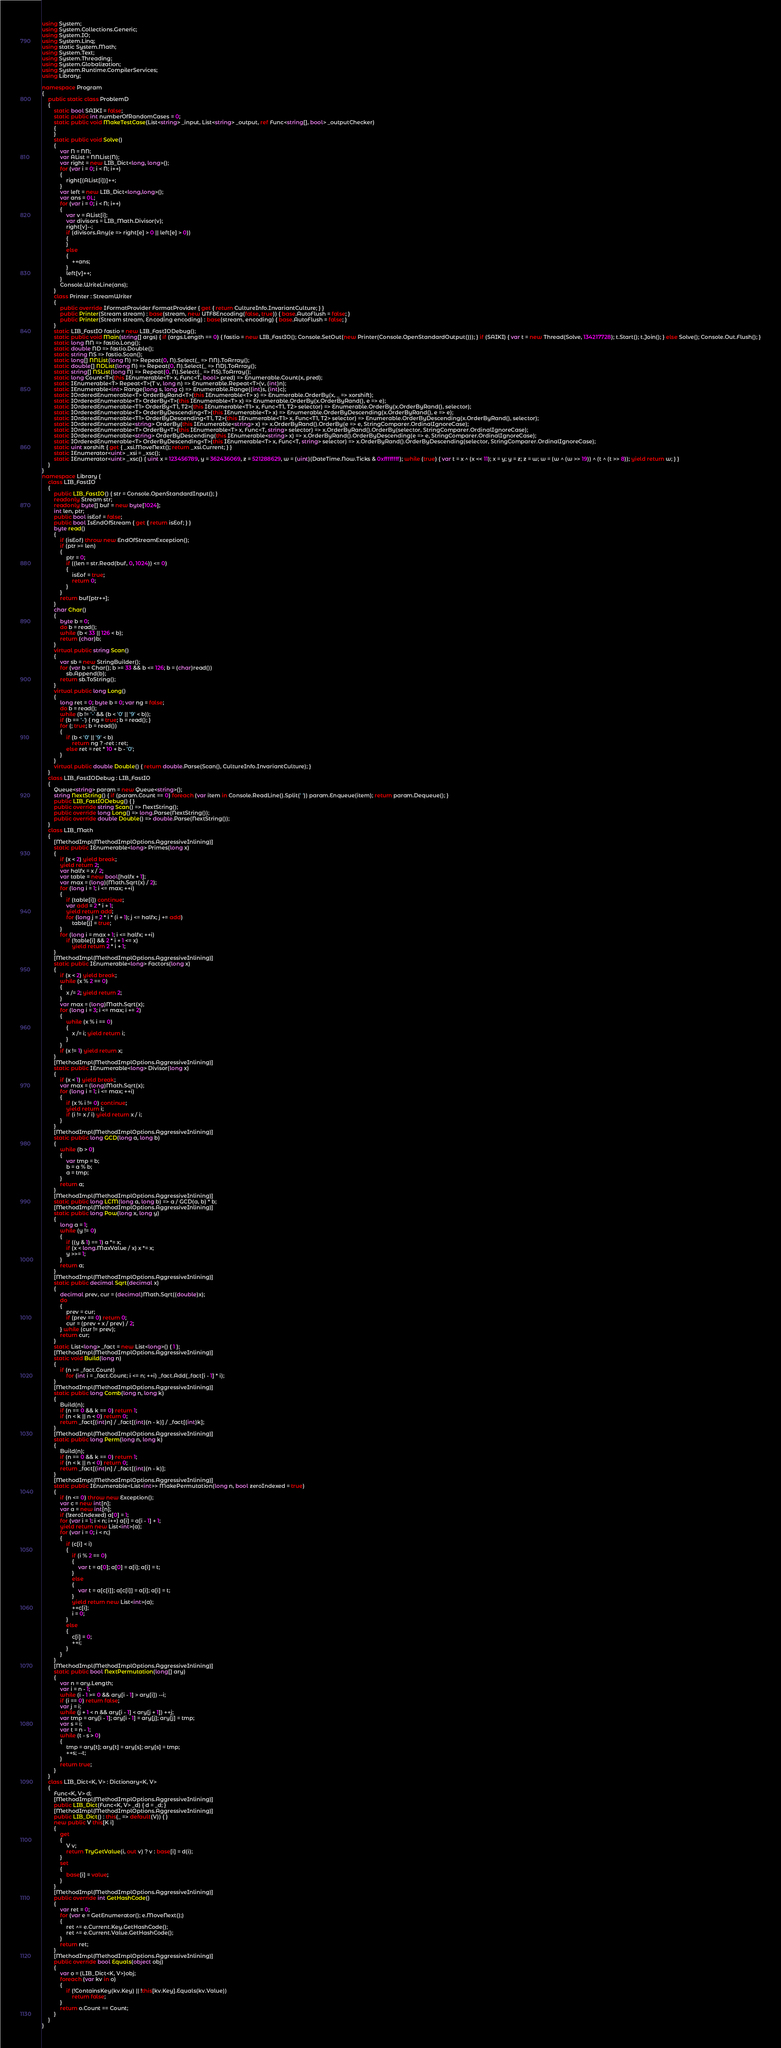<code> <loc_0><loc_0><loc_500><loc_500><_C#_>using System;
using System.Collections.Generic;
using System.IO;
using System.Linq;
using static System.Math;
using System.Text;
using System.Threading;
using System.Globalization;
using System.Runtime.CompilerServices;
using Library;

namespace Program
{
    public static class ProblemD
    {
        static bool SAIKI = false;
        static public int numberOfRandomCases = 0;
        static public void MakeTestCase(List<string> _input, List<string> _output, ref Func<string[], bool> _outputChecker)
        {
        }
        static public void Solve()
        {
            var N = NN;
            var AList = NNList(N);
            var right = new LIB_Dict<long, long>();
            for (var i = 0; i < N; i++)
            {
                right[(AList[i])]++;
            }
            var left = new LIB_Dict<long,long>();
            var ans = 0L;
            for (var i = 0; i < N; i++)
            {
                var v = AList[i];
                var divisors = LIB_Math.Divisor(v);
                right[v]--;
                if (divisors.Any(e => right[e] > 0 || left[e] > 0))
                {
                }
                else
                {
                    ++ans;
                }
                left[v]++;
            }
            Console.WriteLine(ans);
        }
        class Printer : StreamWriter
        {
            public override IFormatProvider FormatProvider { get { return CultureInfo.InvariantCulture; } }
            public Printer(Stream stream) : base(stream, new UTF8Encoding(false, true)) { base.AutoFlush = false; }
            public Printer(Stream stream, Encoding encoding) : base(stream, encoding) { base.AutoFlush = false; }
        }
        static LIB_FastIO fastio = new LIB_FastIODebug();
        static public void Main(string[] args) { if (args.Length == 0) { fastio = new LIB_FastIO(); Console.SetOut(new Printer(Console.OpenStandardOutput())); } if (SAIKI) { var t = new Thread(Solve, 134217728); t.Start(); t.Join(); } else Solve(); Console.Out.Flush(); }
        static long NN => fastio.Long();
        static double ND => fastio.Double();
        static string NS => fastio.Scan();
        static long[] NNList(long N) => Repeat(0, N).Select(_ => NN).ToArray();
        static double[] NDList(long N) => Repeat(0, N).Select(_ => ND).ToArray();
        static string[] NSList(long N) => Repeat(0, N).Select(_ => NS).ToArray();
        static long Count<T>(this IEnumerable<T> x, Func<T, bool> pred) => Enumerable.Count(x, pred);
        static IEnumerable<T> Repeat<T>(T v, long n) => Enumerable.Repeat<T>(v, (int)n);
        static IEnumerable<int> Range(long s, long c) => Enumerable.Range((int)s, (int)c);
        static IOrderedEnumerable<T> OrderByRand<T>(this IEnumerable<T> x) => Enumerable.OrderBy(x, _ => xorshift);
        static IOrderedEnumerable<T> OrderBy<T>(this IEnumerable<T> x) => Enumerable.OrderBy(x.OrderByRand(), e => e);
        static IOrderedEnumerable<T1> OrderBy<T1, T2>(this IEnumerable<T1> x, Func<T1, T2> selector) => Enumerable.OrderBy(x.OrderByRand(), selector);
        static IOrderedEnumerable<T> OrderByDescending<T>(this IEnumerable<T> x) => Enumerable.OrderByDescending(x.OrderByRand(), e => e);
        static IOrderedEnumerable<T1> OrderByDescending<T1, T2>(this IEnumerable<T1> x, Func<T1, T2> selector) => Enumerable.OrderByDescending(x.OrderByRand(), selector);
        static IOrderedEnumerable<string> OrderBy(this IEnumerable<string> x) => x.OrderByRand().OrderBy(e => e, StringComparer.OrdinalIgnoreCase);
        static IOrderedEnumerable<T> OrderBy<T>(this IEnumerable<T> x, Func<T, string> selector) => x.OrderByRand().OrderBy(selector, StringComparer.OrdinalIgnoreCase);
        static IOrderedEnumerable<string> OrderByDescending(this IEnumerable<string> x) => x.OrderByRand().OrderByDescending(e => e, StringComparer.OrdinalIgnoreCase);
        static IOrderedEnumerable<T> OrderByDescending<T>(this IEnumerable<T> x, Func<T, string> selector) => x.OrderByRand().OrderByDescending(selector, StringComparer.OrdinalIgnoreCase);
        static uint xorshift { get { _xsi.MoveNext(); return _xsi.Current; } }
        static IEnumerator<uint> _xsi = _xsc();
        static IEnumerator<uint> _xsc() { uint x = 123456789, y = 362436069, z = 521288629, w = (uint)(DateTime.Now.Ticks & 0xffffffff); while (true) { var t = x ^ (x << 11); x = y; y = z; z = w; w = (w ^ (w >> 19)) ^ (t ^ (t >> 8)); yield return w; } }
    }
}
namespace Library {
    class LIB_FastIO
    {
        public LIB_FastIO() { str = Console.OpenStandardInput(); }
        readonly Stream str;
        readonly byte[] buf = new byte[1024];
        int len, ptr;
        public bool isEof = false;
        public bool IsEndOfStream { get { return isEof; } }
        byte read()
        {
            if (isEof) throw new EndOfStreamException();
            if (ptr >= len)
            {
                ptr = 0;
                if ((len = str.Read(buf, 0, 1024)) <= 0)
                {
                    isEof = true;
                    return 0;
                }
            }
            return buf[ptr++];
        }
        char Char()
        {
            byte b = 0;
            do b = read();
            while (b < 33 || 126 < b);
            return (char)b;
        }
        virtual public string Scan()
        {
            var sb = new StringBuilder();
            for (var b = Char(); b >= 33 && b <= 126; b = (char)read())
                sb.Append(b);
            return sb.ToString();
        }
        virtual public long Long()
        {
            long ret = 0; byte b = 0; var ng = false;
            do b = read();
            while (b != '-' && (b < '0' || '9' < b));
            if (b == '-') { ng = true; b = read(); }
            for (; true; b = read())
            {
                if (b < '0' || '9' < b)
                    return ng ? -ret : ret;
                else ret = ret * 10 + b - '0';
            }
        }
        virtual public double Double() { return double.Parse(Scan(), CultureInfo.InvariantCulture); }
    }
    class LIB_FastIODebug : LIB_FastIO
    {
        Queue<string> param = new Queue<string>();
        string NextString() { if (param.Count == 0) foreach (var item in Console.ReadLine().Split(' ')) param.Enqueue(item); return param.Dequeue(); }
        public LIB_FastIODebug() { }
        public override string Scan() => NextString();
        public override long Long() => long.Parse(NextString());
        public override double Double() => double.Parse(NextString());
    }
    class LIB_Math
    {
        [MethodImpl(MethodImplOptions.AggressiveInlining)]
        static public IEnumerable<long> Primes(long x)
        {
            if (x < 2) yield break;
            yield return 2;
            var halfx = x / 2;
            var table = new bool[halfx + 1];
            var max = (long)(Math.Sqrt(x) / 2);
            for (long i = 1; i <= max; ++i)
            {
                if (table[i]) continue;
                var add = 2 * i + 1;
                yield return add;
                for (long j = 2 * i * (i + 1); j <= halfx; j += add)
                    table[j] = true;
            }
            for (long i = max + 1; i <= halfx; ++i)
                if (!table[i] && 2 * i + 1 <= x)
                    yield return 2 * i + 1;
        }
        [MethodImpl(MethodImplOptions.AggressiveInlining)]
        static public IEnumerable<long> Factors(long x)
        {
            if (x < 2) yield break;
            while (x % 2 == 0)
            {
                x /= 2; yield return 2;
            }
            var max = (long)Math.Sqrt(x);
            for (long i = 3; i <= max; i += 2)
            {
                while (x % i == 0)
                {
                    x /= i; yield return i;
                }
            }
            if (x != 1) yield return x;
        }
        [MethodImpl(MethodImplOptions.AggressiveInlining)]
        static public IEnumerable<long> Divisor(long x)
        {
            if (x < 1) yield break;
            var max = (long)Math.Sqrt(x);
            for (long i = 1; i <= max; ++i)
            {
                if (x % i != 0) continue;
                yield return i;
                if (i != x / i) yield return x / i;
            }
        }
        [MethodImpl(MethodImplOptions.AggressiveInlining)]
        static public long GCD(long a, long b)
        {
            while (b > 0)
            {
                var tmp = b;
                b = a % b;
                a = tmp;
            }
            return a;
        }
        [MethodImpl(MethodImplOptions.AggressiveInlining)]
        static public long LCM(long a, long b) => a / GCD(a, b) * b;
        [MethodImpl(MethodImplOptions.AggressiveInlining)]
        static public long Pow(long x, long y)
        {
            long a = 1;
            while (y != 0)
            {
                if ((y & 1) == 1) a *= x;
                if (x < long.MaxValue / x) x *= x;
                y >>= 1;
            }
            return a;
        }
        [MethodImpl(MethodImplOptions.AggressiveInlining)]
        static public decimal Sqrt(decimal x)
        {
            decimal prev, cur = (decimal)Math.Sqrt((double)x);
            do
            {
                prev = cur;
                if (prev == 0) return 0;
                cur = (prev + x / prev) / 2;
            } while (cur != prev);
            return cur;
        }
        static List<long> _fact = new List<long>() { 1 };
        [MethodImpl(MethodImplOptions.AggressiveInlining)]
        static void Build(long n)
        {
            if (n >= _fact.Count)
                for (int i = _fact.Count; i <= n; ++i) _fact.Add(_fact[i - 1] * i);
        }
        [MethodImpl(MethodImplOptions.AggressiveInlining)]
        static public long Comb(long n, long k)
        {
            Build(n);
            if (n == 0 && k == 0) return 1;
            if (n < k || n < 0) return 0;
            return _fact[(int)n] / _fact[(int)(n - k)] / _fact[(int)k];
        }
        [MethodImpl(MethodImplOptions.AggressiveInlining)]
        static public long Perm(long n, long k)
        {
            Build(n);
            if (n == 0 && k == 0) return 1;
            if (n < k || n < 0) return 0;
            return _fact[(int)n] / _fact[(int)(n - k)];
        }
        [MethodImpl(MethodImplOptions.AggressiveInlining)]
        static public IEnumerable<List<int>> MakePermutation(long n, bool zeroIndexed = true)
        {
            if (n <= 0) throw new Exception();
            var c = new int[n];
            var a = new int[n];
            if (!zeroIndexed) a[0] = 1;
            for (var i = 1; i < n; i++) a[i] = a[i - 1] + 1;
            yield return new List<int>(a);
            for (var i = 0; i < n;)
            {
                if (c[i] < i)
                {
                    if (i % 2 == 0)
                    {
                        var t = a[0]; a[0] = a[i]; a[i] = t;
                    }
                    else
                    {
                        var t = a[c[i]]; a[c[i]] = a[i]; a[i] = t;
                    }
                    yield return new List<int>(a);
                    ++c[i];
                    i = 0;
                }
                else
                {
                    c[i] = 0;
                    ++i;
                }
            }
        }
        [MethodImpl(MethodImplOptions.AggressiveInlining)]
        static public bool NextPermutation(long[] ary)
        {
            var n = ary.Length;
            var i = n - 1;
            while (i - 1 >= 0 && ary[i - 1] > ary[i]) --i;
            if (i == 0) return false;
            var j = i;
            while (j + 1 < n && ary[i - 1] < ary[j + 1]) ++j;
            var tmp = ary[i - 1]; ary[i - 1] = ary[j]; ary[j] = tmp;
            var s = i;
            var t = n - 1;
            while (t - s > 0)
            {
                tmp = ary[t]; ary[t] = ary[s]; ary[s] = tmp;
                ++s; --t;
            }
            return true;
        }
    }
    class LIB_Dict<K, V> : Dictionary<K, V>
    {
        Func<K, V> d;
        [MethodImpl(MethodImplOptions.AggressiveInlining)]
        public LIB_Dict(Func<K, V> _d) { d = _d; }
        [MethodImpl(MethodImplOptions.AggressiveInlining)]
        public LIB_Dict() : this(_ => default(V)) { }
        new public V this[K i]
        {
            get
            {
                V v;
                return TryGetValue(i, out v) ? v : base[i] = d(i);
            }
            set
            {
                base[i] = value;
            }
        }
        [MethodImpl(MethodImplOptions.AggressiveInlining)]
        public override int GetHashCode()
        {
            var ret = 0;
            for (var e = GetEnumerator(); e.MoveNext();)
            {
                ret ^= e.Current.Key.GetHashCode();
                ret ^= e.Current.Value.GetHashCode();
            }
            return ret;
        }
        [MethodImpl(MethodImplOptions.AggressiveInlining)]
        public override bool Equals(object obj)
        {
            var o = (LIB_Dict<K, V>)obj;
            foreach (var kv in o)
            {
                if (!ContainsKey(kv.Key) || !this[kv.Key].Equals(kv.Value))
                    return false;
            }
            return o.Count == Count;
        }
    }
}
</code> 